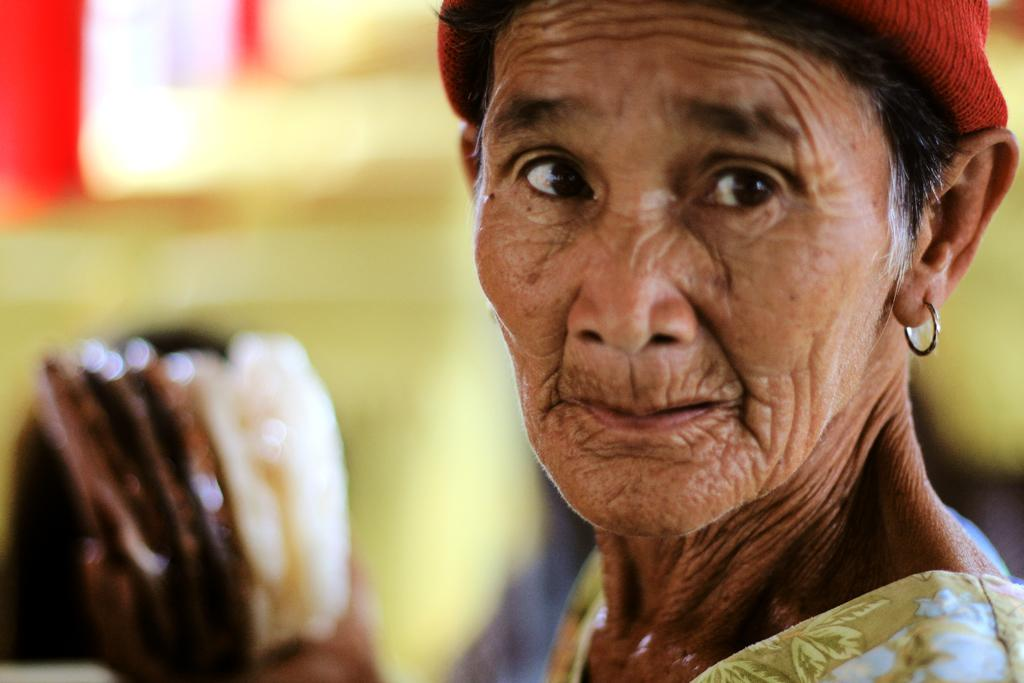Who is the main subject in the image? There is a woman in the image. Where is the woman located in the image? The woman is towards the right side of the image. What is the woman wearing on her head? The woman is wearing a cap. What can be seen towards the bottom of the image? There is an object towards the bottom of the image. How would you describe the background of the image? The background of the image is blurred. How many giraffes can be seen in the image? There are no giraffes present in the image. What type of division is being performed by the woman in the image? There is no division being performed by the woman in the image. 